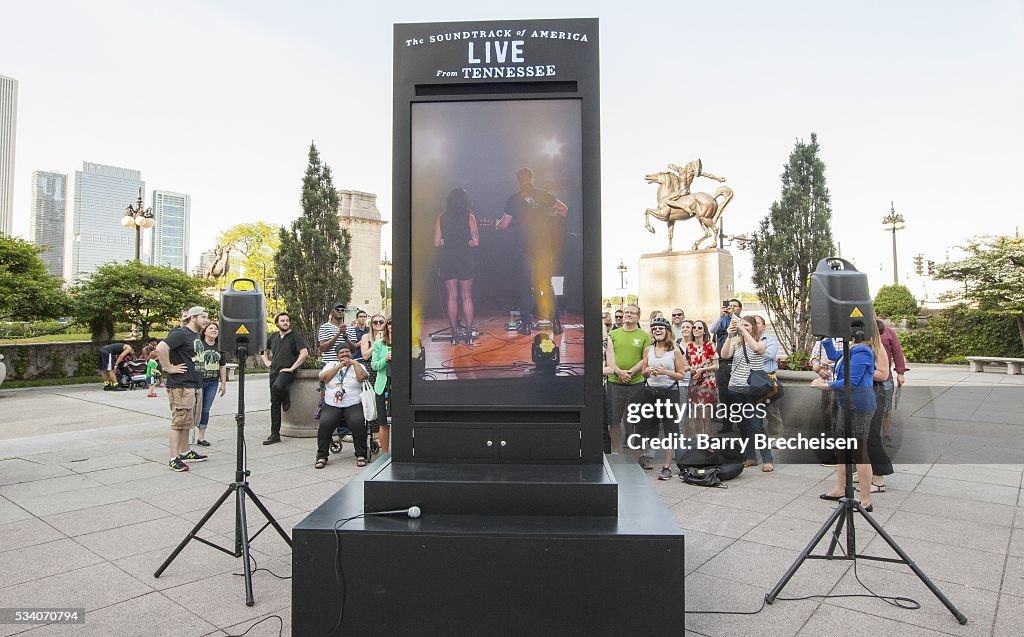What type of event do you think is being captured in this image, and what might be the significance of the background sculpture and urban skyline? The image seems to capture a live outdoor event, possibly a concert or public performance in an urban setting. The presence of speakers and a screen showing performers reinforces this idea. The background sculpture, which appears to be a statue of a horse and rider, could signify a place of historical or cultural importance, adding a sense of gravitas and history to the modern event. The urban skyline in the background indicates that this event is taking place in a city park or public area surrounded by high-rise buildings, suggesting the city's blend of modernity and tradition. Do you think this event is significant to the local community, and why? This event likely holds significant value to the local community as it appears to bring people together in a shared public space, allowing for communal engagement and entertainment. Such events are often important for community bonding, offering a sense of belonging and cultural enrichment. The presence of families, friends, and individuals of diverse backgrounds highlights the inclusive nature of the event, suggesting its role in fostering unity and community spirit. Imagine that this event is the annual highlight for the city. Describe the atmosphere and activities taking place. The atmosphere at this annual city highlight is electric and buzzing with excitement. People from all walks of life converge in this public space, enjoying the array of activities available. The air is filled with the sounds of live music, laughter, and conversations. Food stalls offer a variety of local and international cuisine, inviting visitors to taste different flavors. Children are seen playing and participating in fun games, while art installations and street performances captivate the audience's imagination. The statue of the horse and rider, a historical emblem, stands as a proud sentinel over the festivities, reminding everyone of the city's rich past. Against the backdrop of modern skyscrapers, the scene represents a harmony between tradition and contemporary culture, embodying the city's spirit and identity. 